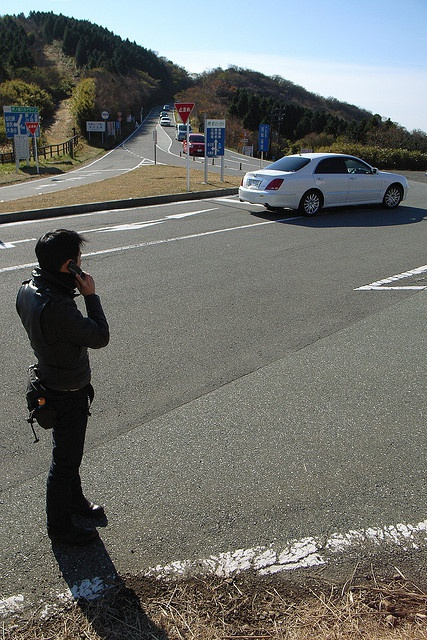Describe the objects in this image and their specific colors. I can see people in lightblue, black, gray, darkgray, and maroon tones, car in lightblue, gray, black, and white tones, car in lightblue, black, maroon, gray, and brown tones, car in lightblue, black, navy, gray, and blue tones, and cell phone in black, gray, and lightblue tones in this image. 